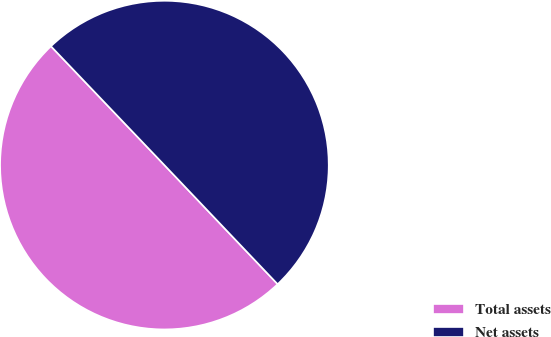Convert chart. <chart><loc_0><loc_0><loc_500><loc_500><pie_chart><fcel>Total assets<fcel>Net assets<nl><fcel>49.97%<fcel>50.03%<nl></chart> 